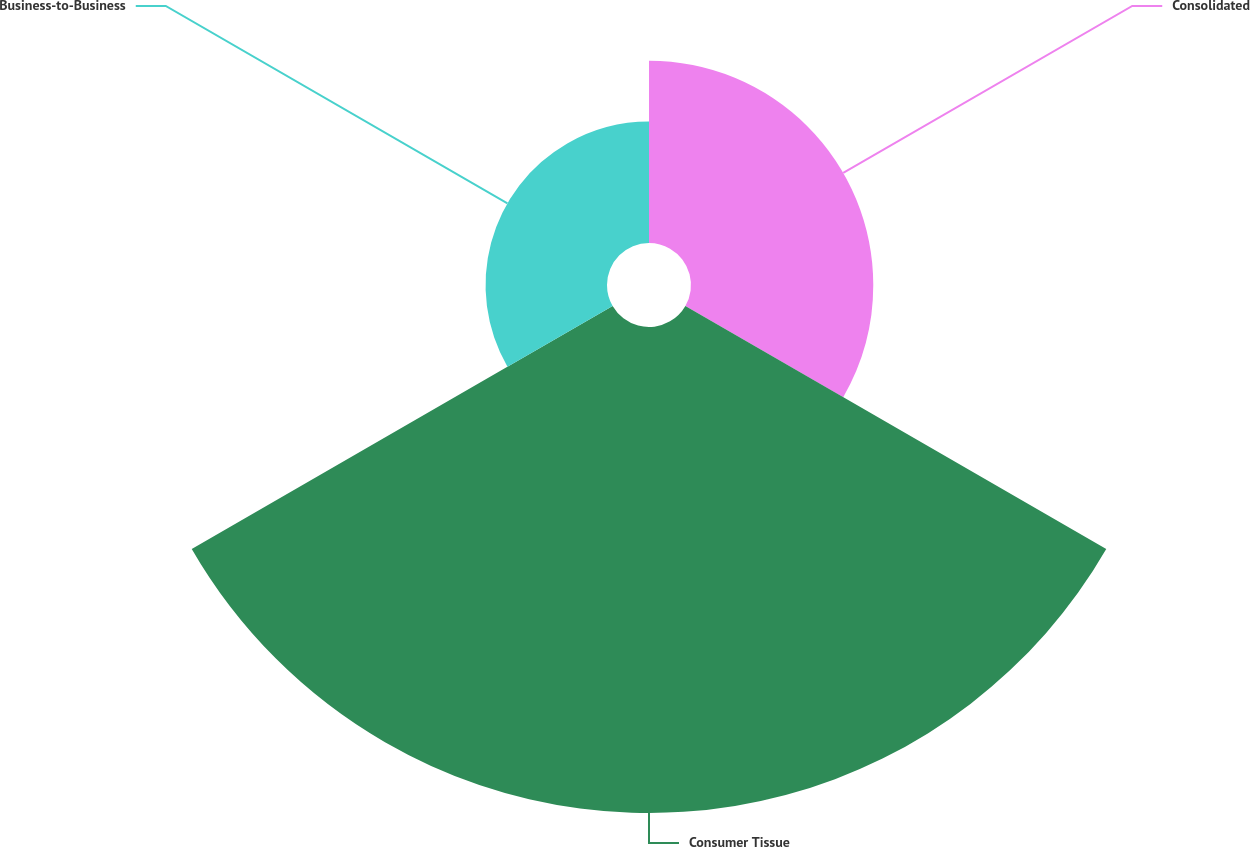<chart> <loc_0><loc_0><loc_500><loc_500><pie_chart><fcel>Consolidated<fcel>Consumer Tissue<fcel>Business-to-Business<nl><fcel>23.08%<fcel>61.54%<fcel>15.38%<nl></chart> 